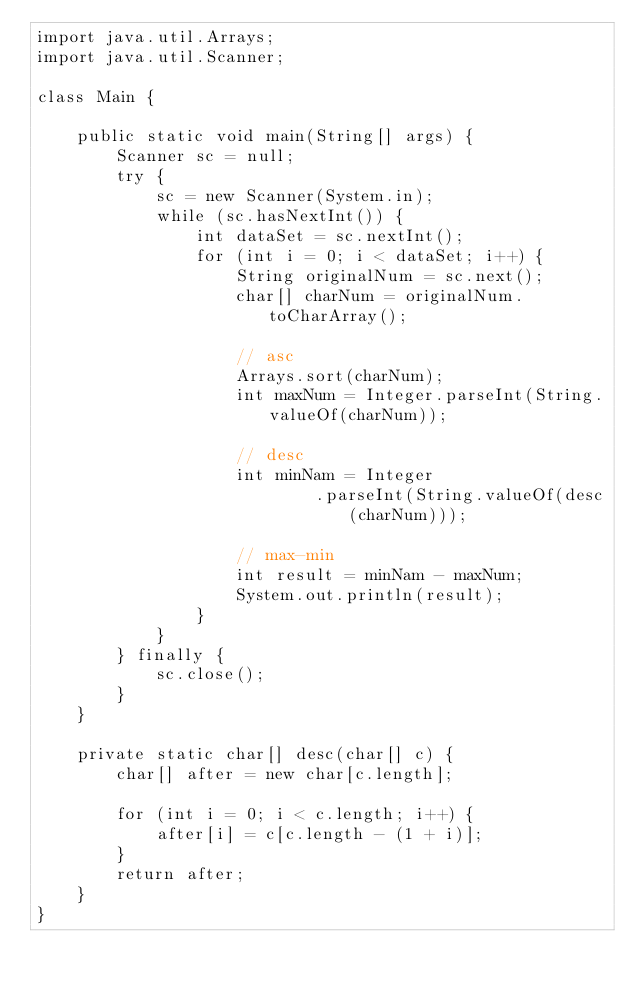<code> <loc_0><loc_0><loc_500><loc_500><_Java_>import java.util.Arrays;
import java.util.Scanner;

class Main {

    public static void main(String[] args) {
        Scanner sc = null;
        try {
            sc = new Scanner(System.in);
            while (sc.hasNextInt()) {
                int dataSet = sc.nextInt();
                for (int i = 0; i < dataSet; i++) {
                    String originalNum = sc.next();
                    char[] charNum = originalNum.toCharArray();

                    // asc
                    Arrays.sort(charNum);
                    int maxNum = Integer.parseInt(String.valueOf(charNum));

                    // desc
                    int minNam = Integer
                            .parseInt(String.valueOf(desc(charNum)));

                    // max-min
                    int result = minNam - maxNum;
                    System.out.println(result);
                }
            }
        } finally {
            sc.close();
        }
    }

    private static char[] desc(char[] c) {
        char[] after = new char[c.length];

        for (int i = 0; i < c.length; i++) {
            after[i] = c[c.length - (1 + i)];
        }
        return after;
    }
}</code> 